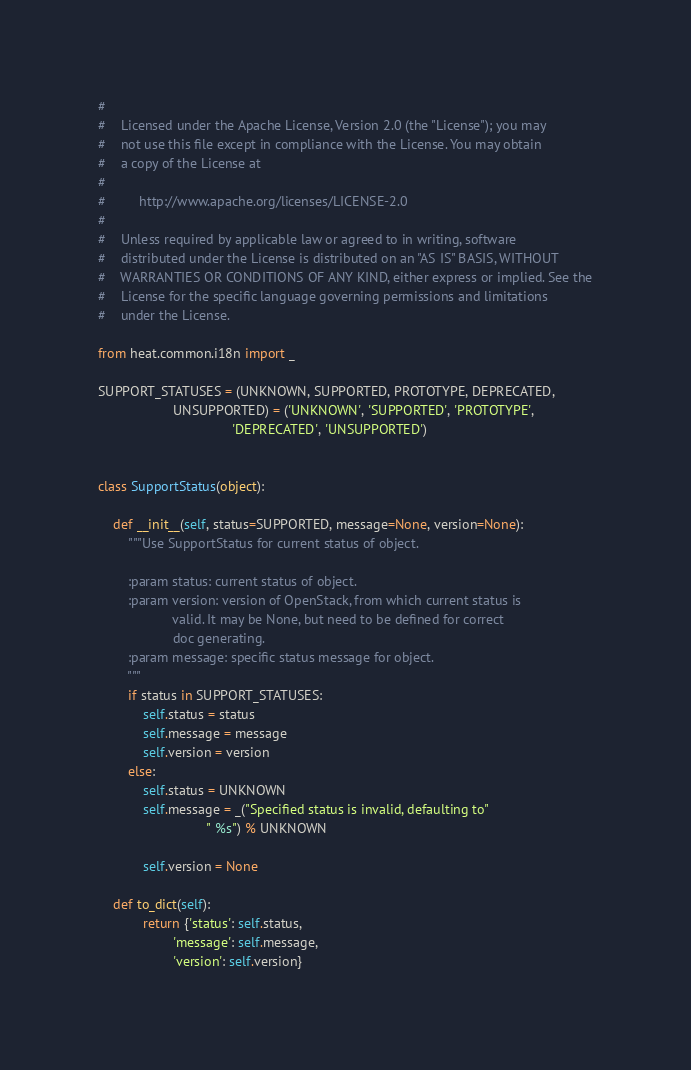<code> <loc_0><loc_0><loc_500><loc_500><_Python_>#
#    Licensed under the Apache License, Version 2.0 (the "License"); you may
#    not use this file except in compliance with the License. You may obtain
#    a copy of the License at
#
#         http://www.apache.org/licenses/LICENSE-2.0
#
#    Unless required by applicable law or agreed to in writing, software
#    distributed under the License is distributed on an "AS IS" BASIS, WITHOUT
#    WARRANTIES OR CONDITIONS OF ANY KIND, either express or implied. See the
#    License for the specific language governing permissions and limitations
#    under the License.

from heat.common.i18n import _

SUPPORT_STATUSES = (UNKNOWN, SUPPORTED, PROTOTYPE, DEPRECATED,
                    UNSUPPORTED) = ('UNKNOWN', 'SUPPORTED', 'PROTOTYPE',
                                    'DEPRECATED', 'UNSUPPORTED')


class SupportStatus(object):

    def __init__(self, status=SUPPORTED, message=None, version=None):
        """Use SupportStatus for current status of object.

        :param status: current status of object.
        :param version: version of OpenStack, from which current status is
                    valid. It may be None, but need to be defined for correct
                    doc generating.
        :param message: specific status message for object.
        """
        if status in SUPPORT_STATUSES:
            self.status = status
            self.message = message
            self.version = version
        else:
            self.status = UNKNOWN
            self.message = _("Specified status is invalid, defaulting to"
                             " %s") % UNKNOWN

            self.version = None

    def to_dict(self):
            return {'status': self.status,
                    'message': self.message,
                    'version': self.version}
</code> 